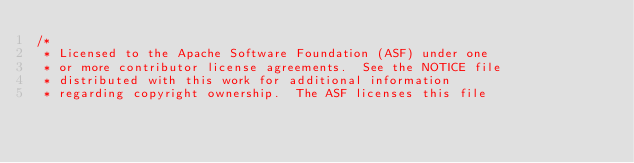<code> <loc_0><loc_0><loc_500><loc_500><_Java_>/*
 * Licensed to the Apache Software Foundation (ASF) under one
 * or more contributor license agreements.  See the NOTICE file
 * distributed with this work for additional information
 * regarding copyright ownership.  The ASF licenses this file</code> 